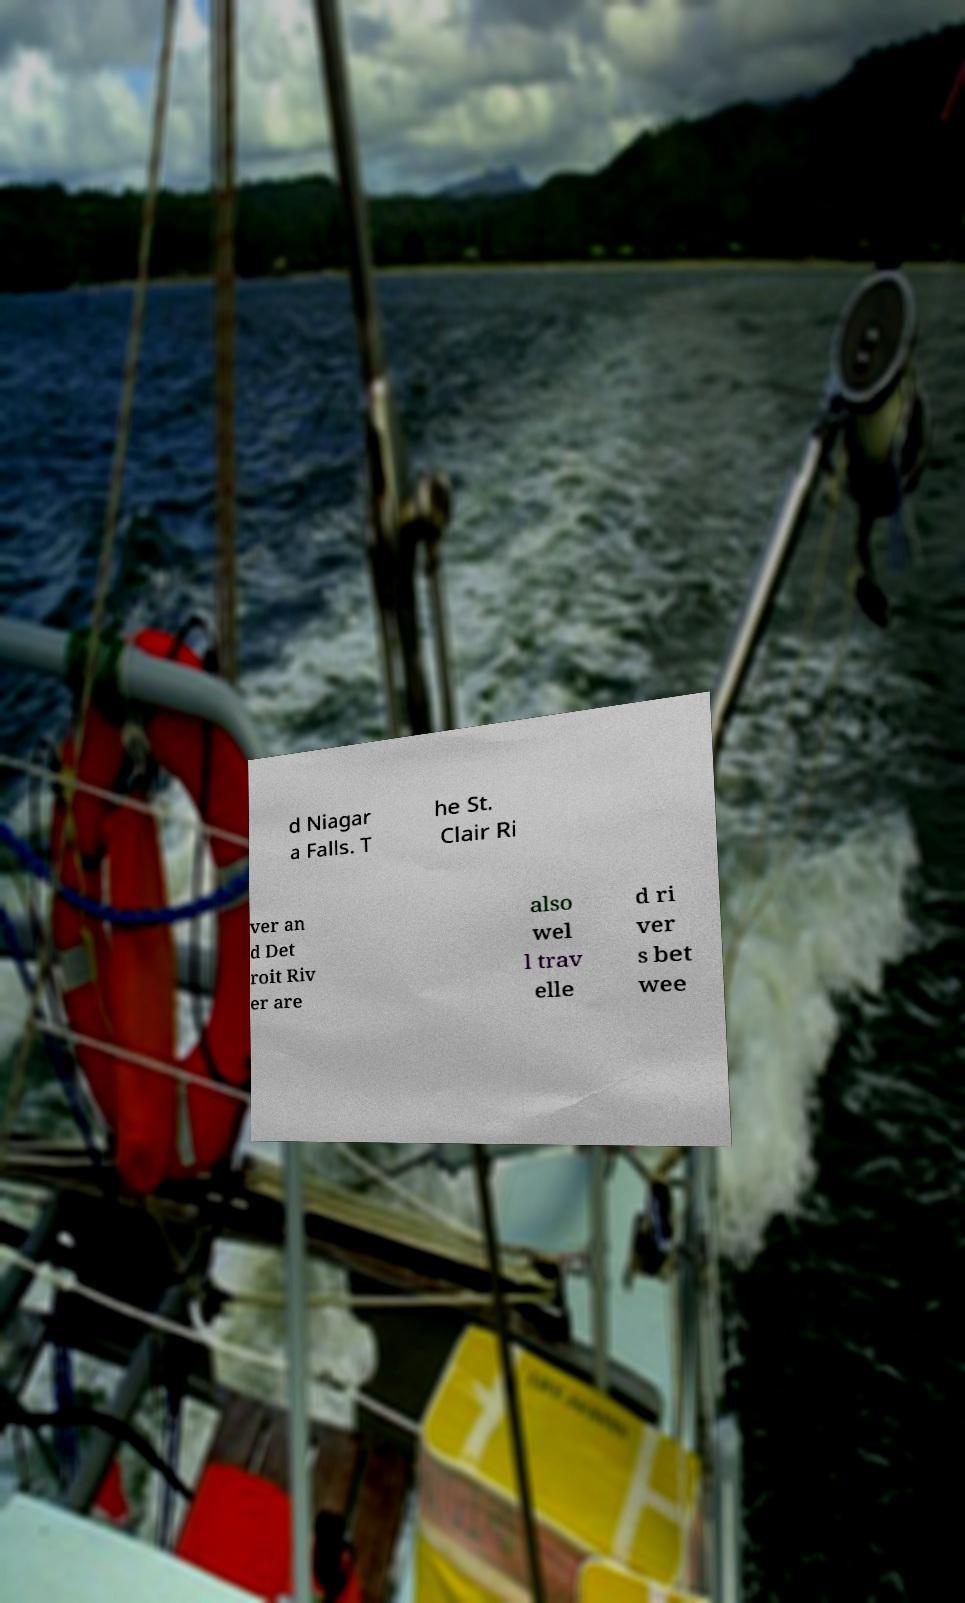Please identify and transcribe the text found in this image. d Niagar a Falls. T he St. Clair Ri ver an d Det roit Riv er are also wel l trav elle d ri ver s bet wee 